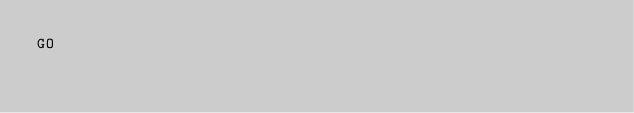<code> <loc_0><loc_0><loc_500><loc_500><_SQL_>GO</code> 